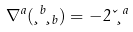Convert formula to latex. <formula><loc_0><loc_0><loc_500><loc_500>\nabla ^ { a } ( \xi ^ { b } \xi _ { b } ) = - 2 \kappa \xi ^ { a }</formula> 